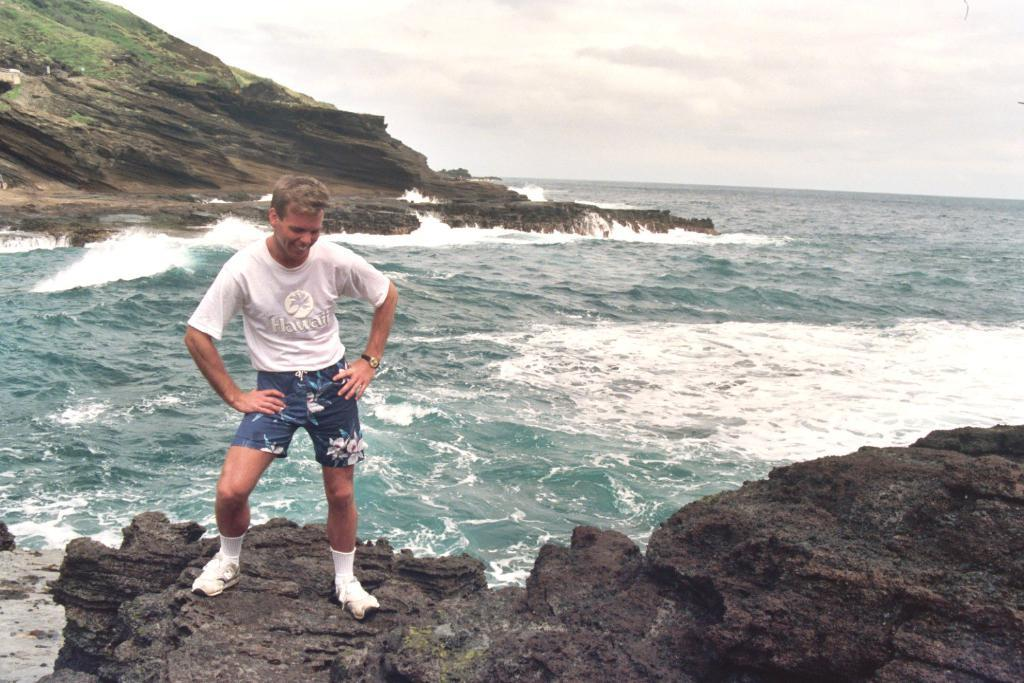What is present in the image? There is a person in the image. What type of terrain can be seen in the image? The ground is visible in the image, and there is grass present. What geographical feature is visible in the image? There is a mountain in the image. What natural element is visible in the image? There is water visible in the image. What part of the natural environment is visible in the image? The sky is visible in the image. What type of feast is being held in the image? There is no feast present in the image; it features a person in a natural environment. Who is the representative of the group in the image? There is no group or representative present in the image; it features a person in a natural environment. 